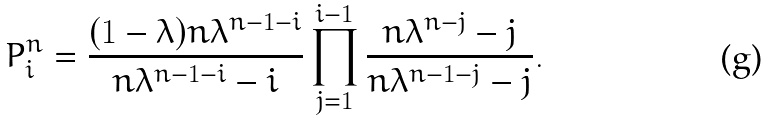<formula> <loc_0><loc_0><loc_500><loc_500>P ^ { n } _ { i } = \frac { ( 1 - \lambda ) n \lambda ^ { n - 1 - i } } { n \lambda ^ { n - 1 - i } - i } \prod _ { j = 1 } ^ { i - 1 } \frac { n \lambda ^ { n - j } - j } { n \lambda ^ { n - 1 - j } - j } .</formula> 